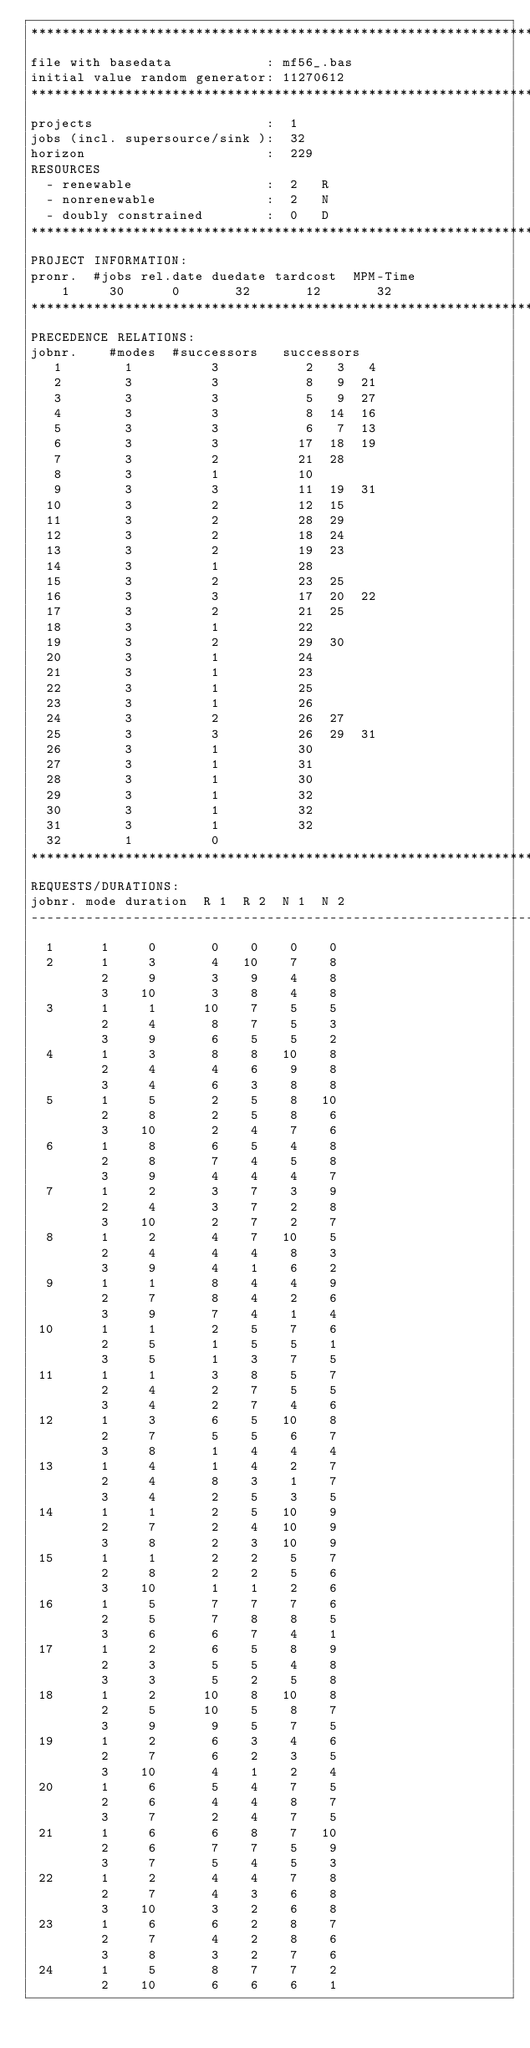<code> <loc_0><loc_0><loc_500><loc_500><_ObjectiveC_>************************************************************************
file with basedata            : mf56_.bas
initial value random generator: 11270612
************************************************************************
projects                      :  1
jobs (incl. supersource/sink ):  32
horizon                       :  229
RESOURCES
  - renewable                 :  2   R
  - nonrenewable              :  2   N
  - doubly constrained        :  0   D
************************************************************************
PROJECT INFORMATION:
pronr.  #jobs rel.date duedate tardcost  MPM-Time
    1     30      0       32       12       32
************************************************************************
PRECEDENCE RELATIONS:
jobnr.    #modes  #successors   successors
   1        1          3           2   3   4
   2        3          3           8   9  21
   3        3          3           5   9  27
   4        3          3           8  14  16
   5        3          3           6   7  13
   6        3          3          17  18  19
   7        3          2          21  28
   8        3          1          10
   9        3          3          11  19  31
  10        3          2          12  15
  11        3          2          28  29
  12        3          2          18  24
  13        3          2          19  23
  14        3          1          28
  15        3          2          23  25
  16        3          3          17  20  22
  17        3          2          21  25
  18        3          1          22
  19        3          2          29  30
  20        3          1          24
  21        3          1          23
  22        3          1          25
  23        3          1          26
  24        3          2          26  27
  25        3          3          26  29  31
  26        3          1          30
  27        3          1          31
  28        3          1          30
  29        3          1          32
  30        3          1          32
  31        3          1          32
  32        1          0        
************************************************************************
REQUESTS/DURATIONS:
jobnr. mode duration  R 1  R 2  N 1  N 2
------------------------------------------------------------------------
  1      1     0       0    0    0    0
  2      1     3       4   10    7    8
         2     9       3    9    4    8
         3    10       3    8    4    8
  3      1     1      10    7    5    5
         2     4       8    7    5    3
         3     9       6    5    5    2
  4      1     3       8    8   10    8
         2     4       4    6    9    8
         3     4       6    3    8    8
  5      1     5       2    5    8   10
         2     8       2    5    8    6
         3    10       2    4    7    6
  6      1     8       6    5    4    8
         2     8       7    4    5    8
         3     9       4    4    4    7
  7      1     2       3    7    3    9
         2     4       3    7    2    8
         3    10       2    7    2    7
  8      1     2       4    7   10    5
         2     4       4    4    8    3
         3     9       4    1    6    2
  9      1     1       8    4    4    9
         2     7       8    4    2    6
         3     9       7    4    1    4
 10      1     1       2    5    7    6
         2     5       1    5    5    1
         3     5       1    3    7    5
 11      1     1       3    8    5    7
         2     4       2    7    5    5
         3     4       2    7    4    6
 12      1     3       6    5   10    8
         2     7       5    5    6    7
         3     8       1    4    4    4
 13      1     4       1    4    2    7
         2     4       8    3    1    7
         3     4       2    5    3    5
 14      1     1       2    5   10    9
         2     7       2    4   10    9
         3     8       2    3   10    9
 15      1     1       2    2    5    7
         2     8       2    2    5    6
         3    10       1    1    2    6
 16      1     5       7    7    7    6
         2     5       7    8    8    5
         3     6       6    7    4    1
 17      1     2       6    5    8    9
         2     3       5    5    4    8
         3     3       5    2    5    8
 18      1     2      10    8   10    8
         2     5      10    5    8    7
         3     9       9    5    7    5
 19      1     2       6    3    4    6
         2     7       6    2    3    5
         3    10       4    1    2    4
 20      1     6       5    4    7    5
         2     6       4    4    8    7
         3     7       2    4    7    5
 21      1     6       6    8    7   10
         2     6       7    7    5    9
         3     7       5    4    5    3
 22      1     2       4    4    7    8
         2     7       4    3    6    8
         3    10       3    2    6    8
 23      1     6       6    2    8    7
         2     7       4    2    8    6
         3     8       3    2    7    6
 24      1     5       8    7    7    2
         2    10       6    6    6    1</code> 